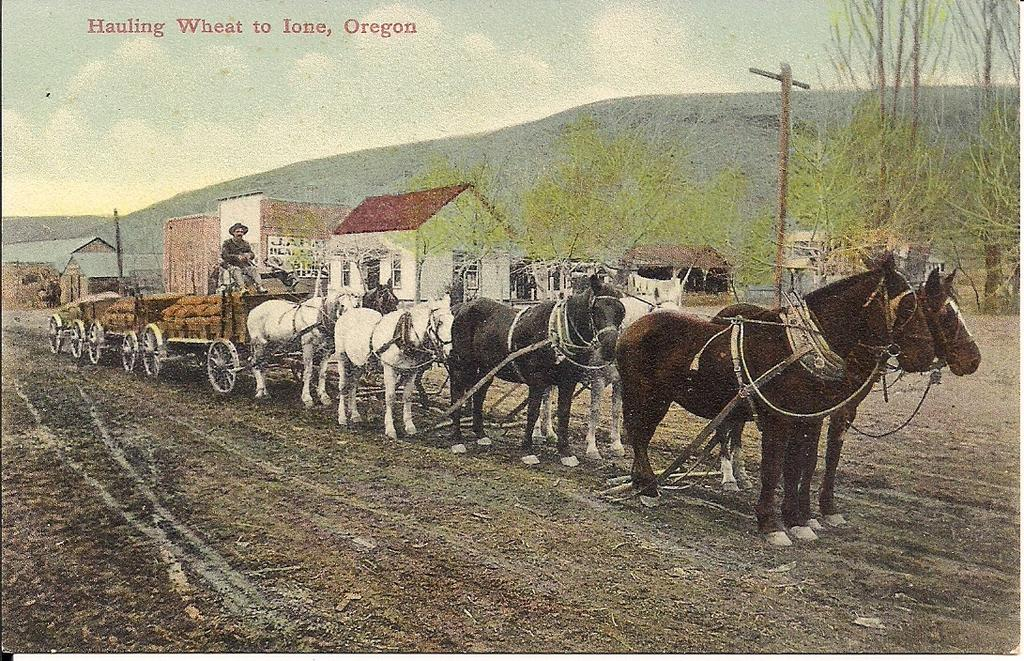What is present on the poster in the image? There is a poster in the image that contains both text and images. Can you describe the content of the poster? The poster contains text and images, but the specific content cannot be determined from the provided facts. How many pies are displayed on the poster in the image? There is no information about pies being present on the poster in the image. 